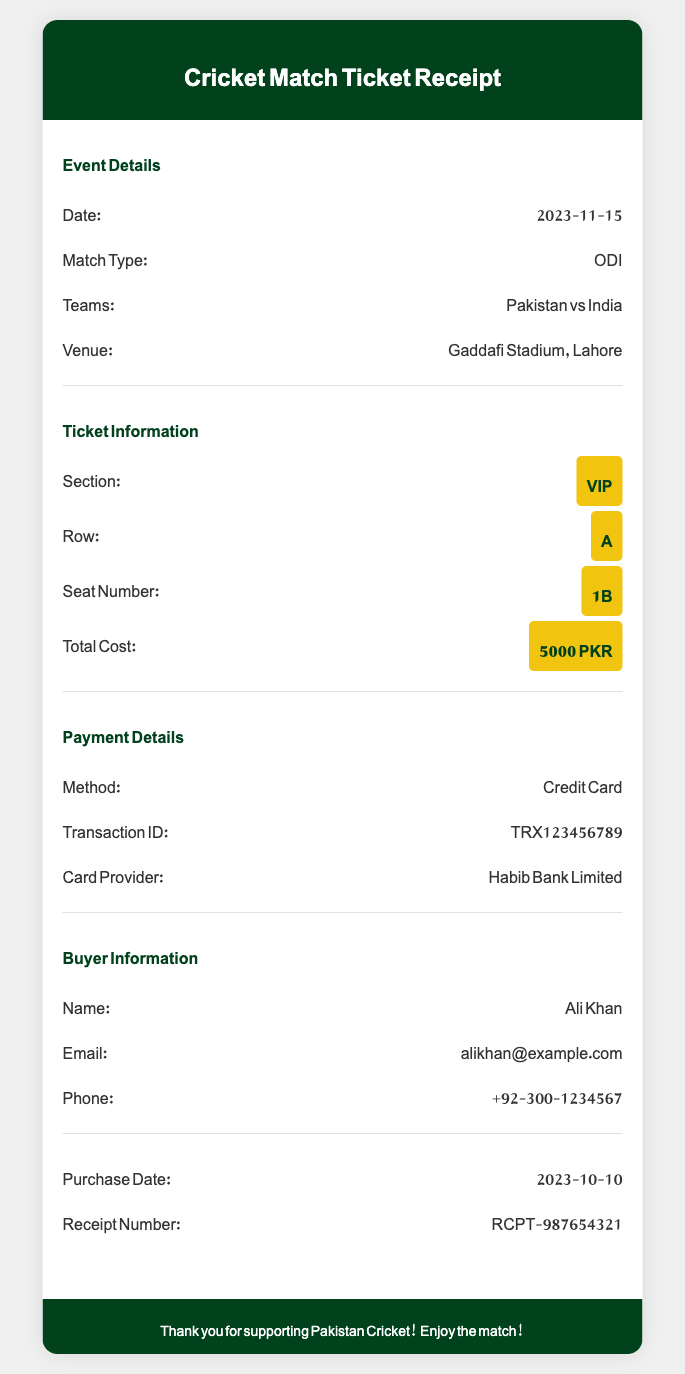What is the date of the match? The date of the match is mentioned in the Event Details section.
Answer: 2023-11-15 Who are the teams playing in the match? The teams playing are listed under the Event Details section.
Answer: Pakistan vs India What is the seat number assigned? The seat number can be found in the Ticket Information section.
Answer: 1B What is the total cost of the ticket? The total cost is specified in the Ticket Information section.
Answer: 5000 PKR What is the payment method used for the ticket purchase? The payment method is stated in the Payment Details section.
Answer: Credit Card What is the transaction ID? The transaction ID is provided in the Payment Details section.
Answer: TRX123456789 When was the ticket purchased? The purchase date is indicated towards the end of the document.
Answer: 2023-10-10 What is the receipt number? The receipt number can be found in the details provided at the end of the document.
Answer: RCPT-987654321 Which bank is the card provider? The card provider is mentioned in the Payment Details.
Answer: Habib Bank Limited 